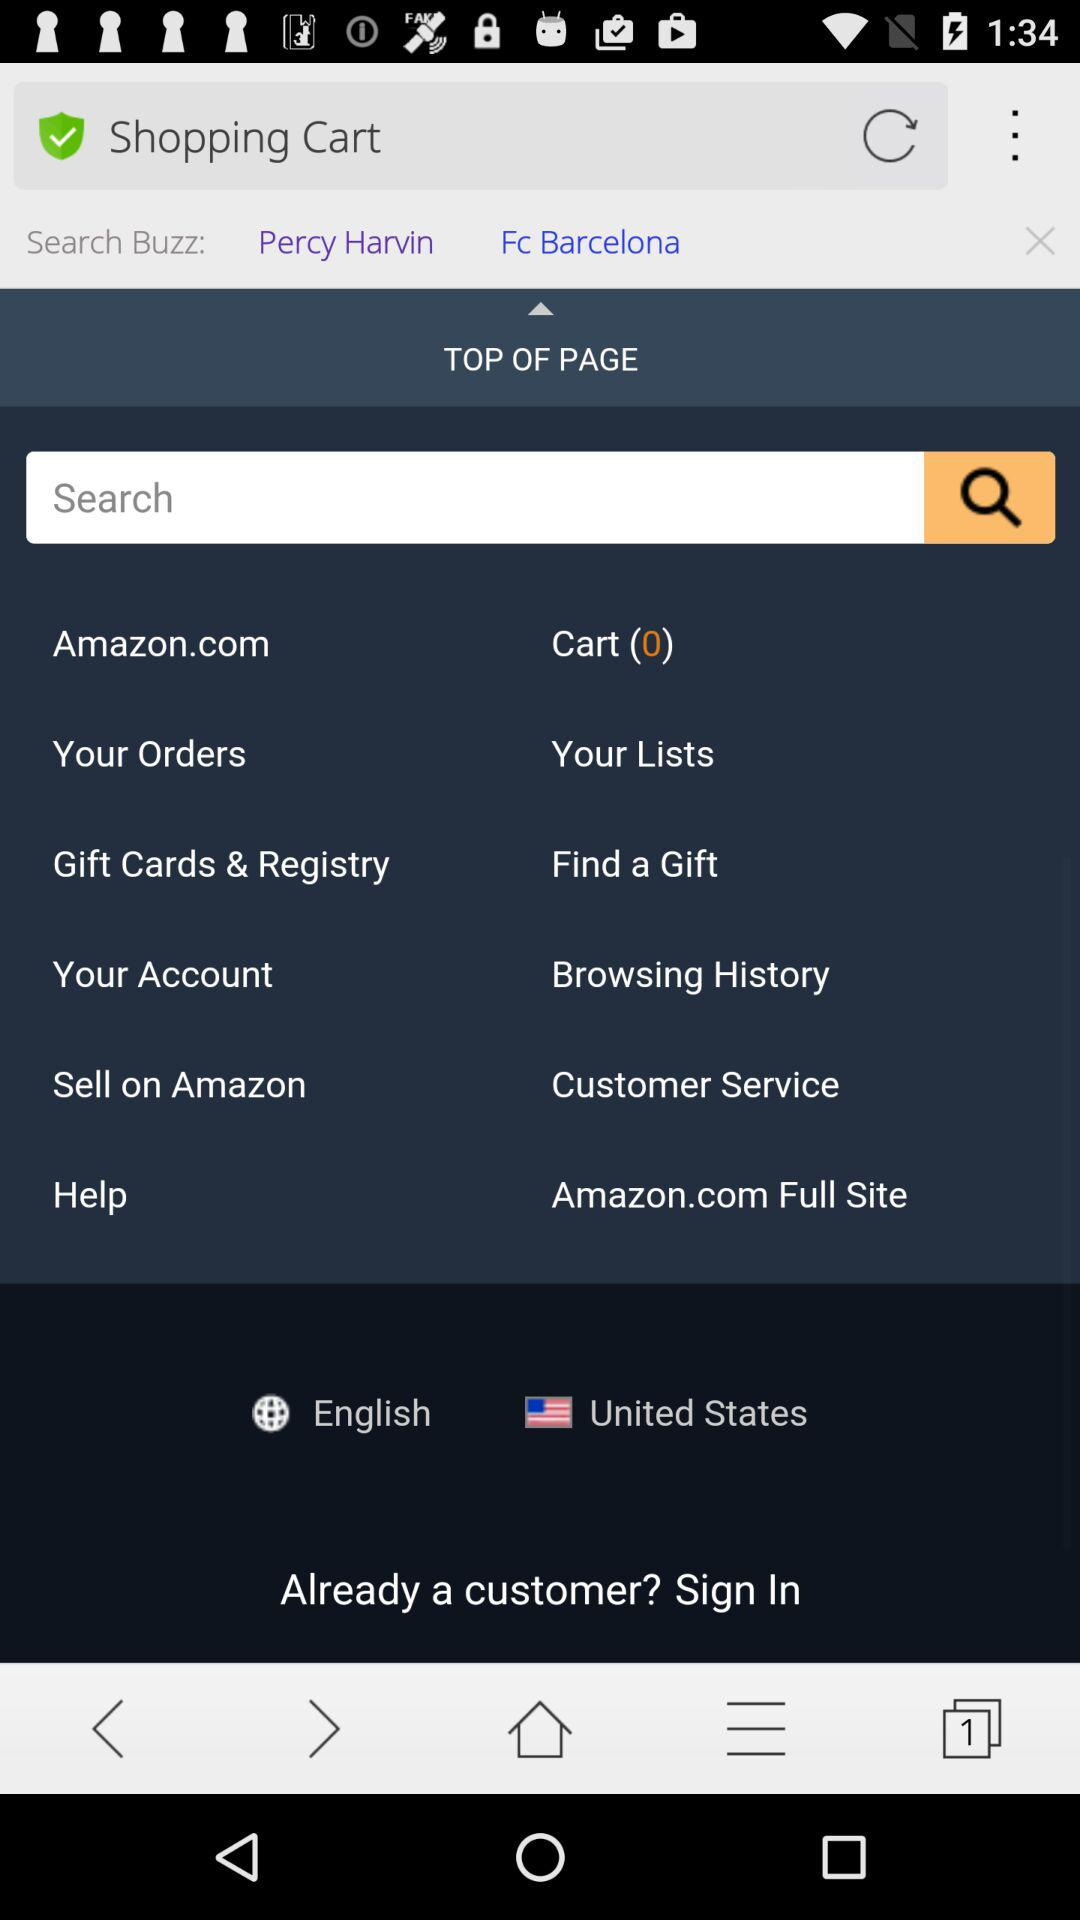What language has been selected? The selected language is English. 